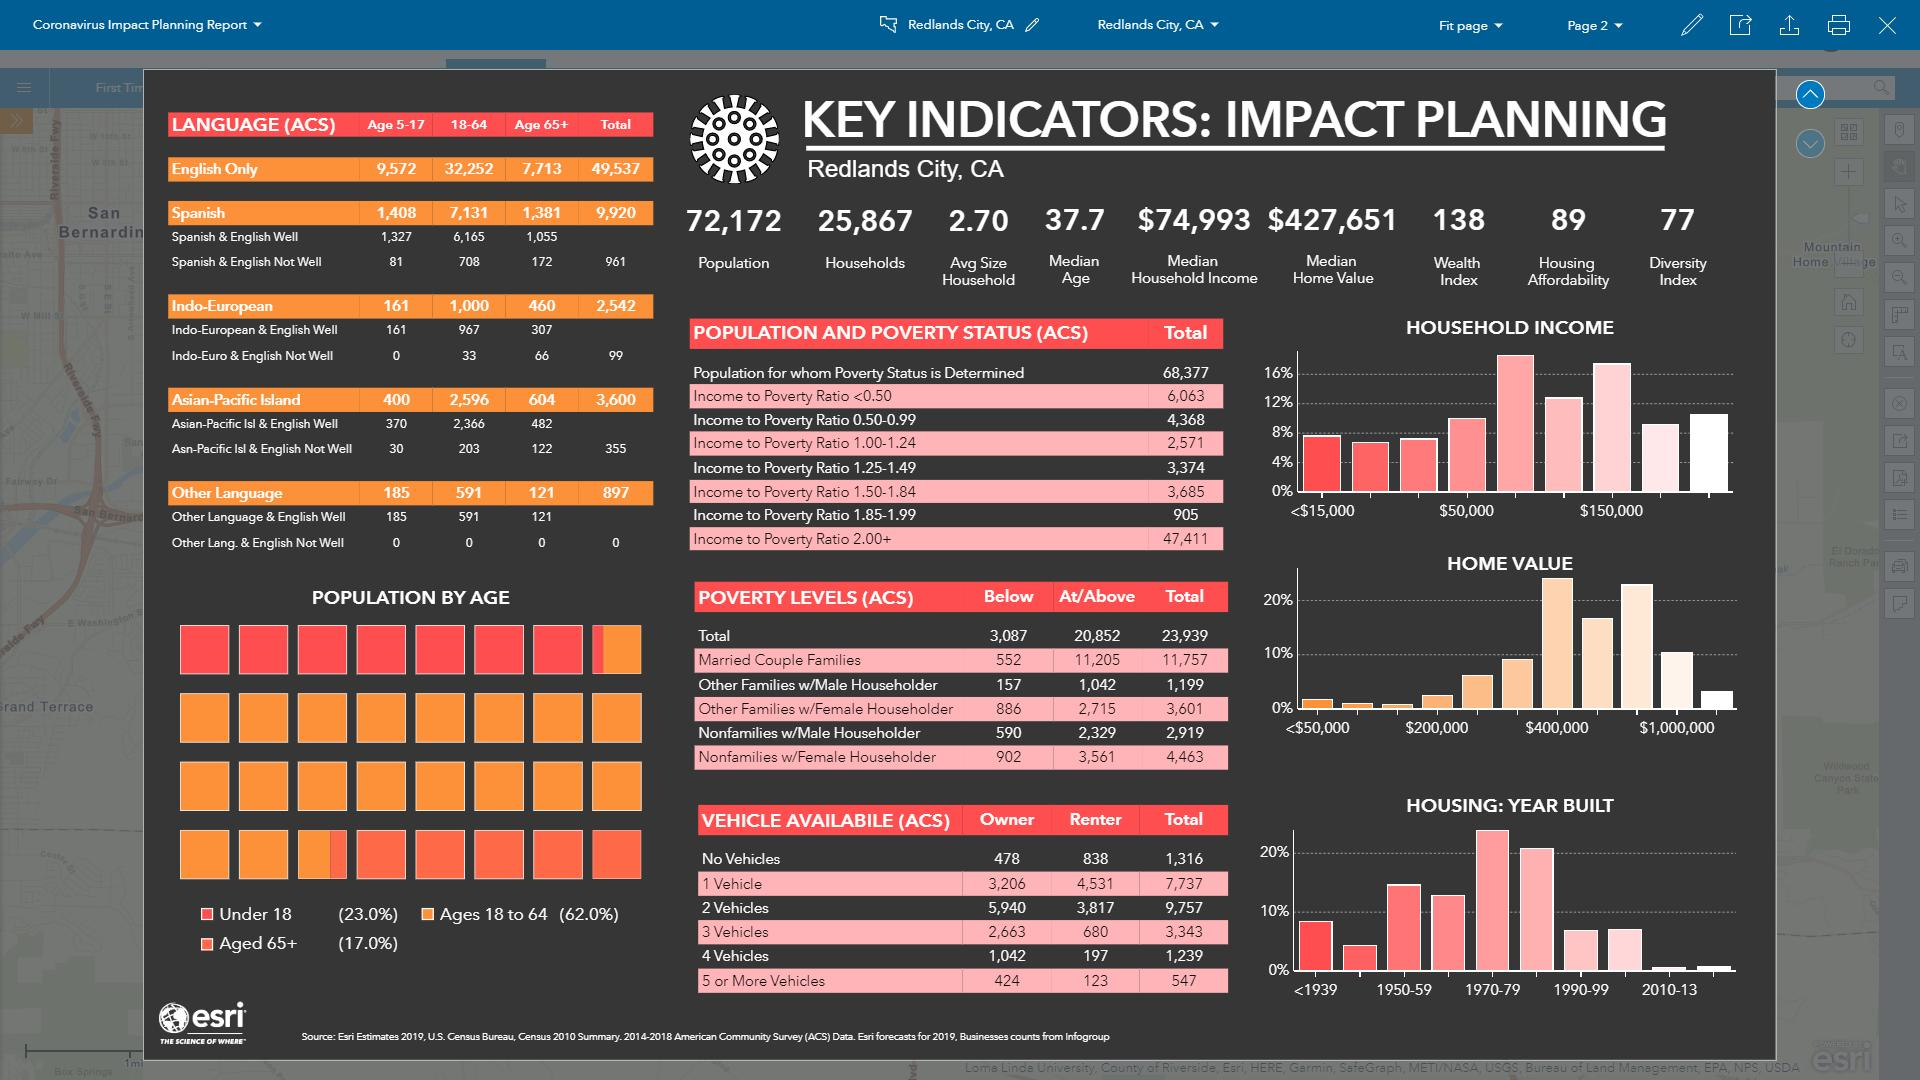Identify some key points in this picture. There are 7,713 people aged 65 and older in Redlands City, California who speak only the English language, according to ACS data. According to the ACS data, there are 1,055 individuals aged 65 and older in the Redlands City, California who speak both English and Spanish fluently. According to the ACS data, there are 161 individuals aged 5-17 years in the Redlands City, California who speak only Indo-European languages. The median home value in the Redlands City, California, is $427,651. The diversity index in Redlands City, California is 77. 